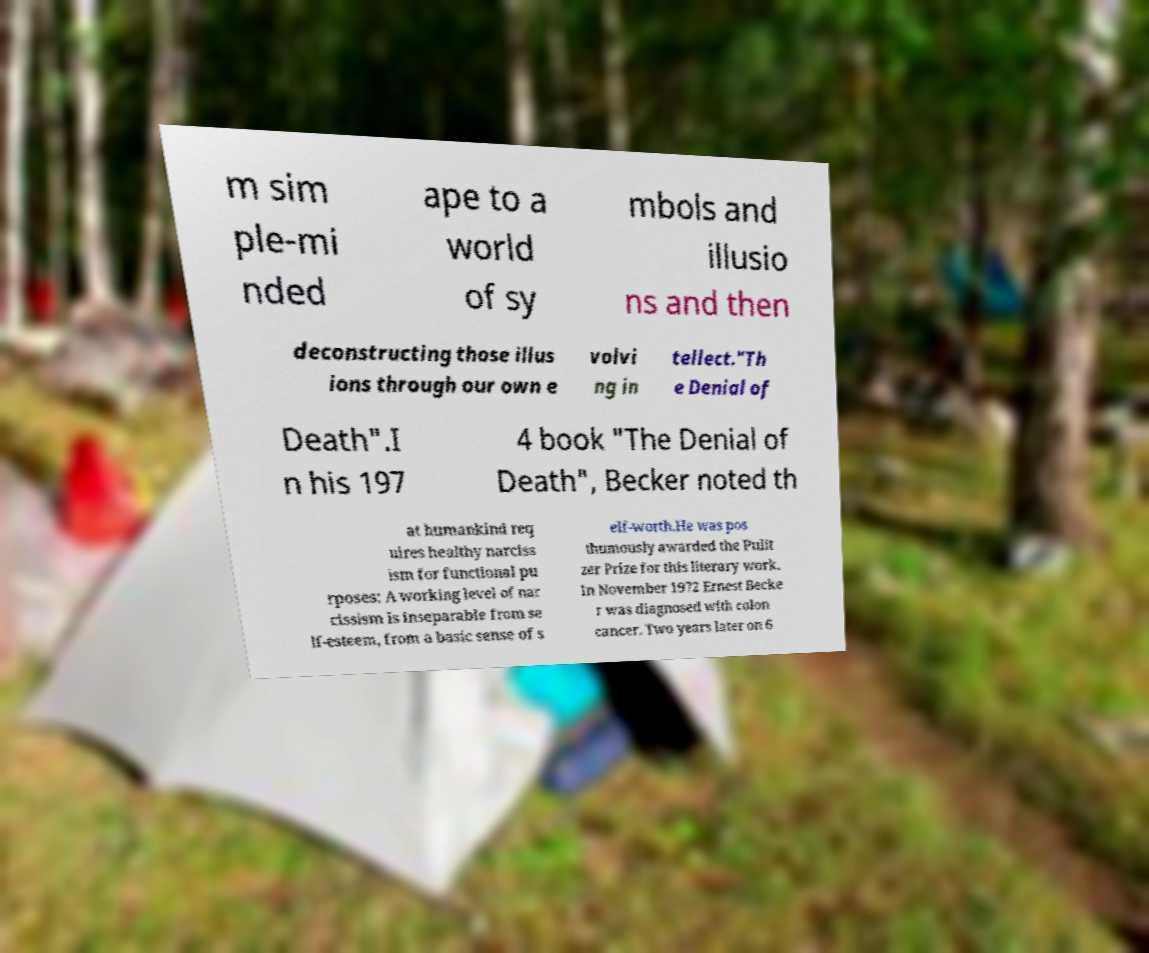Can you accurately transcribe the text from the provided image for me? m sim ple-mi nded ape to a world of sy mbols and illusio ns and then deconstructing those illus ions through our own e volvi ng in tellect."Th e Denial of Death".I n his 197 4 book "The Denial of Death", Becker noted th at humankind req uires healthy narciss ism for functional pu rposes: A working level of nar cissism is inseparable from se lf-esteem, from a basic sense of s elf-worth.He was pos thumously awarded the Pulit zer Prize for this literary work. In November 1972 Ernest Becke r was diagnosed with colon cancer. Two years later on 6 